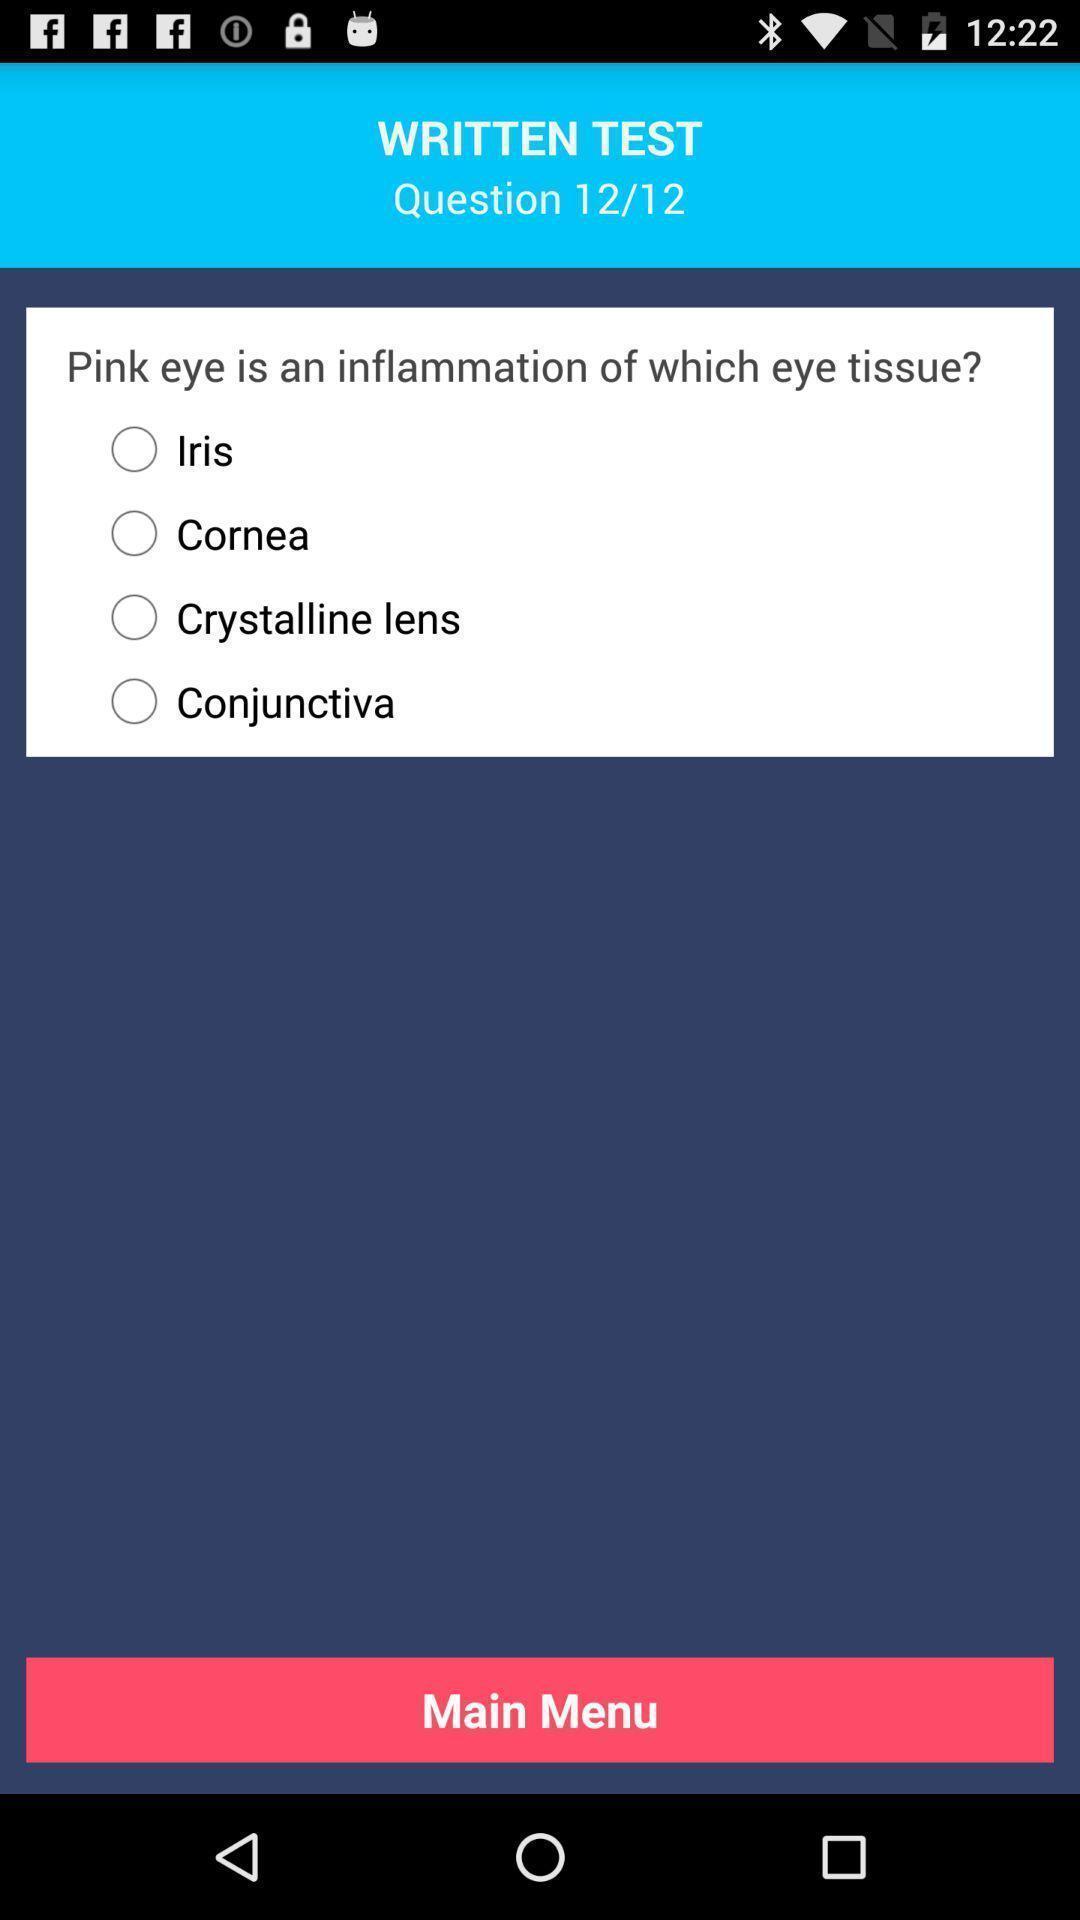Provide a textual representation of this image. Screen page of a learning app. 